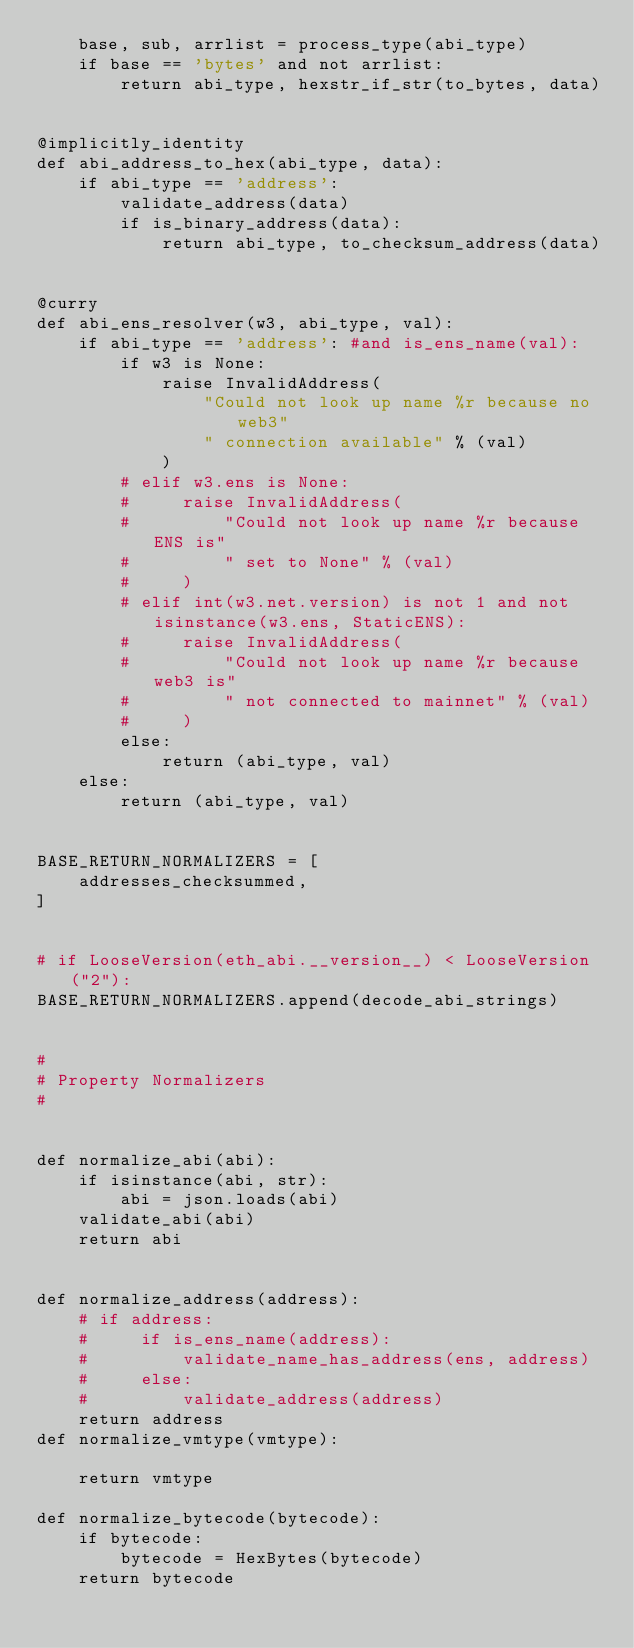<code> <loc_0><loc_0><loc_500><loc_500><_Python_>    base, sub, arrlist = process_type(abi_type)
    if base == 'bytes' and not arrlist:
        return abi_type, hexstr_if_str(to_bytes, data)


@implicitly_identity
def abi_address_to_hex(abi_type, data):
    if abi_type == 'address':
        validate_address(data)
        if is_binary_address(data):
            return abi_type, to_checksum_address(data)


@curry
def abi_ens_resolver(w3, abi_type, val):
    if abi_type == 'address': #and is_ens_name(val):
        if w3 is None:
            raise InvalidAddress(
                "Could not look up name %r because no web3"
                " connection available" % (val)
            )
        # elif w3.ens is None:
        #     raise InvalidAddress(
        #         "Could not look up name %r because ENS is"
        #         " set to None" % (val)
        #     )
        # elif int(w3.net.version) is not 1 and not isinstance(w3.ens, StaticENS):
        #     raise InvalidAddress(
        #         "Could not look up name %r because web3 is"
        #         " not connected to mainnet" % (val)
        #     )
        else:
            return (abi_type, val)
    else:
        return (abi_type, val)


BASE_RETURN_NORMALIZERS = [
    addresses_checksummed,
]


# if LooseVersion(eth_abi.__version__) < LooseVersion("2"):
BASE_RETURN_NORMALIZERS.append(decode_abi_strings)


#
# Property Normalizers
#


def normalize_abi(abi):
    if isinstance(abi, str):
        abi = json.loads(abi)
    validate_abi(abi)
    return abi


def normalize_address(address):
    # if address:
    #     if is_ens_name(address):
    #         validate_name_has_address(ens, address)
    #     else:
    #         validate_address(address)
    return address
def normalize_vmtype(vmtype):

    return vmtype

def normalize_bytecode(bytecode):
    if bytecode:
        bytecode = HexBytes(bytecode)
    return bytecode
</code> 